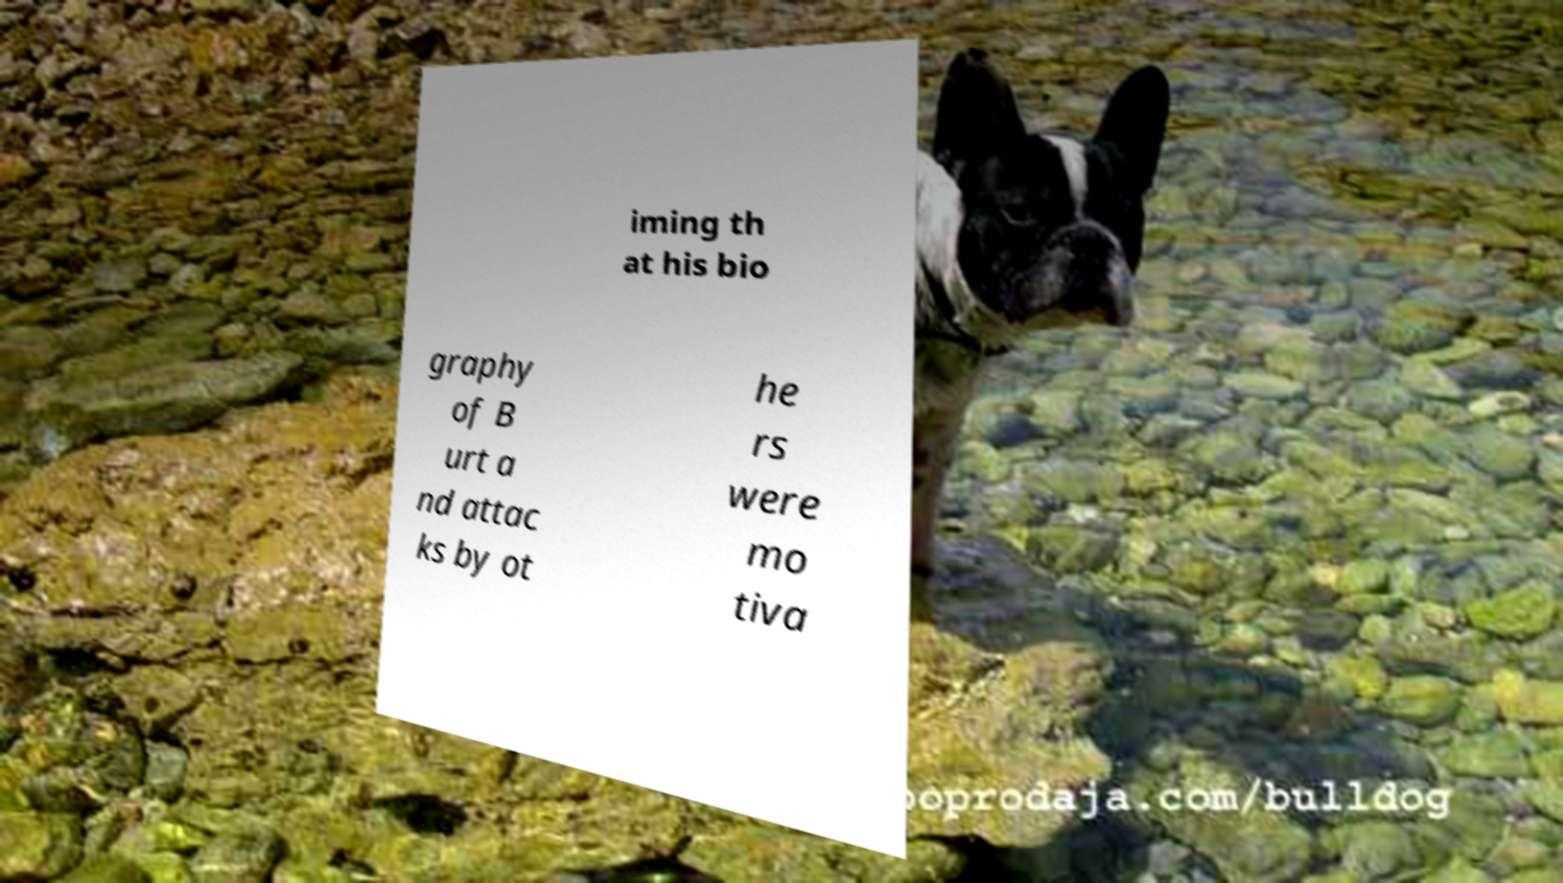What messages or text are displayed in this image? I need them in a readable, typed format. iming th at his bio graphy of B urt a nd attac ks by ot he rs were mo tiva 